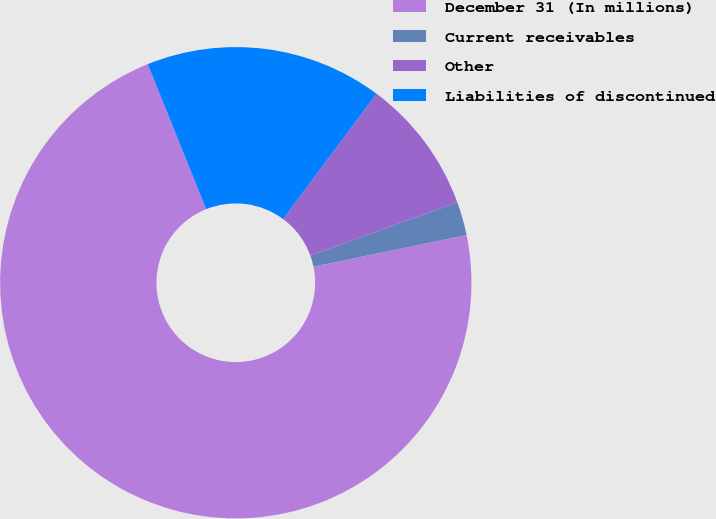Convert chart to OTSL. <chart><loc_0><loc_0><loc_500><loc_500><pie_chart><fcel>December 31 (In millions)<fcel>Current receivables<fcel>Other<fcel>Liabilities of discontinued<nl><fcel>72.15%<fcel>2.3%<fcel>9.28%<fcel>16.27%<nl></chart> 